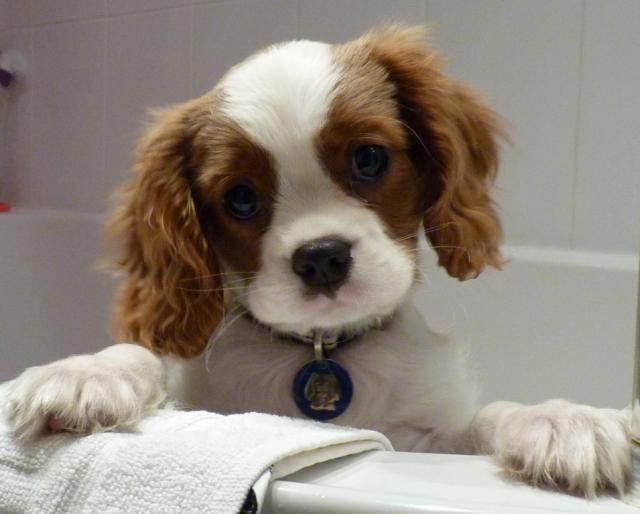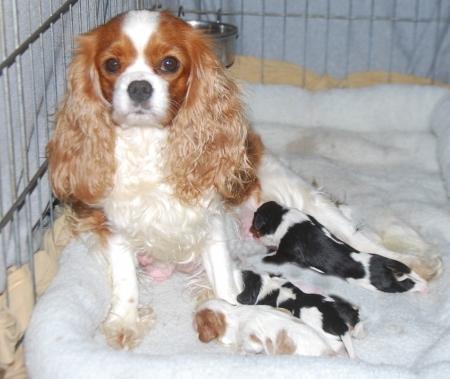The first image is the image on the left, the second image is the image on the right. Evaluate the accuracy of this statement regarding the images: "One image shows a nursing mother spaniel with several spotted puppies.". Is it true? Answer yes or no. Yes. The first image is the image on the left, the second image is the image on the right. For the images displayed, is the sentence "There are 6 total dogs in both images" factually correct? Answer yes or no. No. 